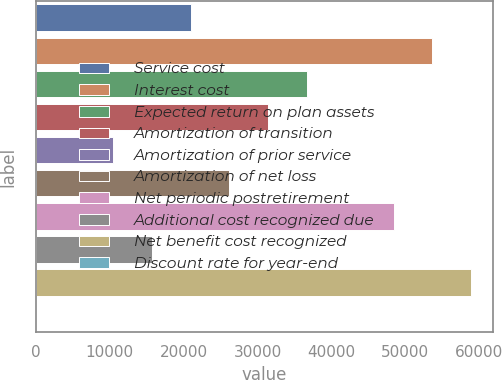<chart> <loc_0><loc_0><loc_500><loc_500><bar_chart><fcel>Service cost<fcel>Interest cost<fcel>Expected return on plan assets<fcel>Amortization of transition<fcel>Amortization of prior service<fcel>Amortization of net loss<fcel>Net periodic postretirement<fcel>Additional cost recognized due<fcel>Net benefit cost recognized<fcel>Discount rate for year-end<nl><fcel>20938.6<fcel>53679.1<fcel>36637.8<fcel>31404.7<fcel>10472.4<fcel>26171.7<fcel>48446<fcel>15705.5<fcel>58912.2<fcel>6.25<nl></chart> 